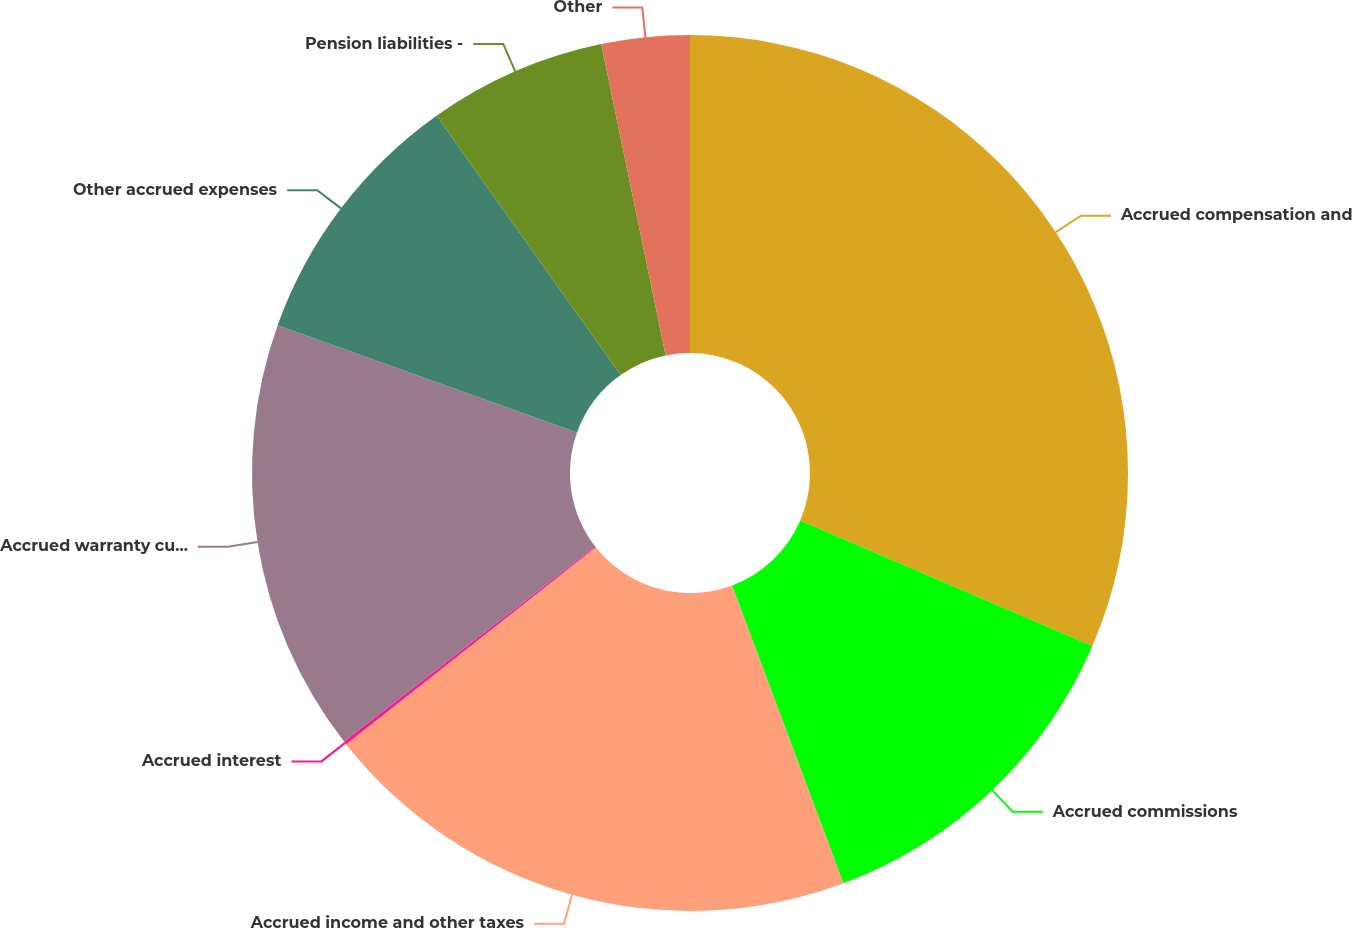Convert chart. <chart><loc_0><loc_0><loc_500><loc_500><pie_chart><fcel>Accrued compensation and<fcel>Accrued commissions<fcel>Accrued income and other taxes<fcel>Accrued interest<fcel>Accrued warranty current<fcel>Other accrued expenses<fcel>Pension liabilities -<fcel>Other<nl><fcel>31.47%<fcel>12.84%<fcel>20.07%<fcel>0.12%<fcel>15.98%<fcel>9.71%<fcel>6.57%<fcel>3.25%<nl></chart> 